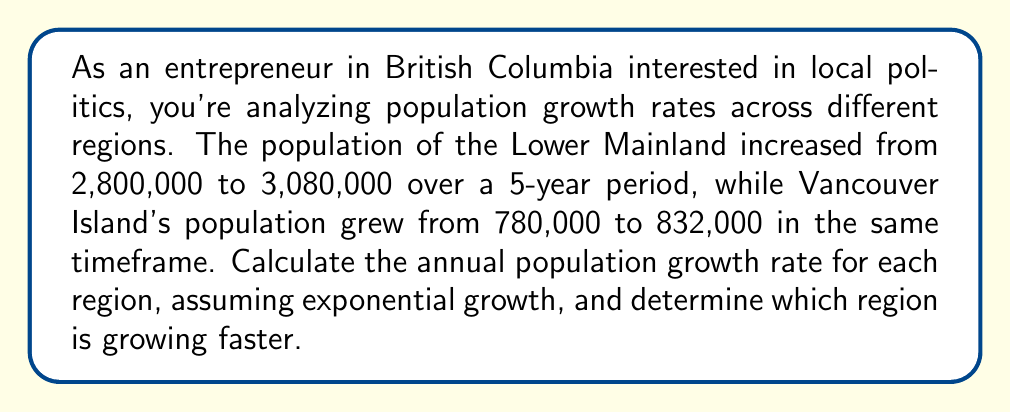Provide a solution to this math problem. To solve this problem, we'll use the exponential growth formula and calculate the annual growth rate for each region:

1. For the Lower Mainland:
   Initial population (P₀) = 2,800,000
   Final population (P) = 3,080,000
   Time period (t) = 5 years

   Using the formula: $P = P_0 \cdot e^{rt}$

   $3,080,000 = 2,800,000 \cdot e^{5r}$

   Dividing both sides by 2,800,000:
   $\frac{3,080,000}{2,800,000} = e^{5r}$

   Taking the natural log of both sides:
   $\ln(\frac{3,080,000}{2,800,000}) = 5r$

   $r = \frac{\ln(\frac{3,080,000}{2,800,000})}{5} \approx 0.0191$ or 1.91% per year

2. For Vancouver Island:
   Initial population (P₀) = 780,000
   Final population (P) = 832,000
   Time period (t) = 5 years

   Using the same formula:
   $832,000 = 780,000 \cdot e^{5r}$

   $\frac{832,000}{780,000} = e^{5r}$

   $\ln(\frac{832,000}{780,000}) = 5r$

   $r = \frac{\ln(\frac{832,000}{780,000})}{5} \approx 0.0129$ or 1.29% per year

Comparing the two growth rates:
Lower Mainland: 1.91% per year
Vancouver Island: 1.29% per year

The Lower Mainland is growing faster with a higher annual growth rate.
Answer: Lower Mainland: 1.91% per year; Vancouver Island: 1.29% per year; Lower Mainland growing faster. 